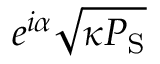Convert formula to latex. <formula><loc_0><loc_0><loc_500><loc_500>e ^ { i \alpha } \sqrt { \kappa P _ { S } }</formula> 